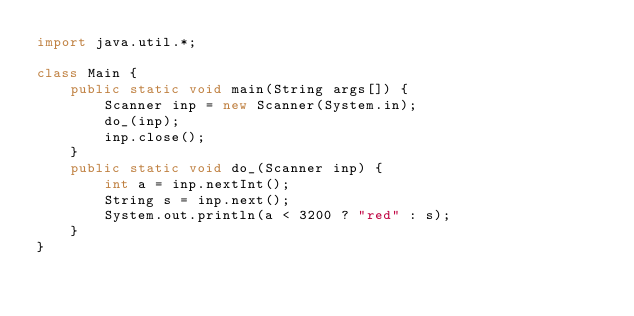Convert code to text. <code><loc_0><loc_0><loc_500><loc_500><_Java_>import java.util.*;

class Main {
    public static void main(String args[]) {
        Scanner inp = new Scanner(System.in);
        do_(inp);
        inp.close();
    }
    public static void do_(Scanner inp) {
        int a = inp.nextInt();
        String s = inp.next();
        System.out.println(a < 3200 ? "red" : s);
    }
}
</code> 